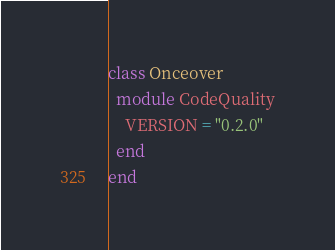<code> <loc_0><loc_0><loc_500><loc_500><_Ruby_>class Onceover
  module CodeQuality
    VERSION = "0.2.0"
  end
end
</code> 